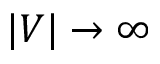Convert formula to latex. <formula><loc_0><loc_0><loc_500><loc_500>| V | \to \infty</formula> 